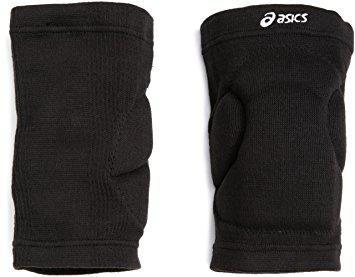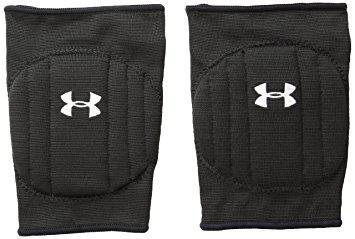The first image is the image on the left, the second image is the image on the right. For the images shown, is this caption "There is at least one white protective pad." true? Answer yes or no. No. 